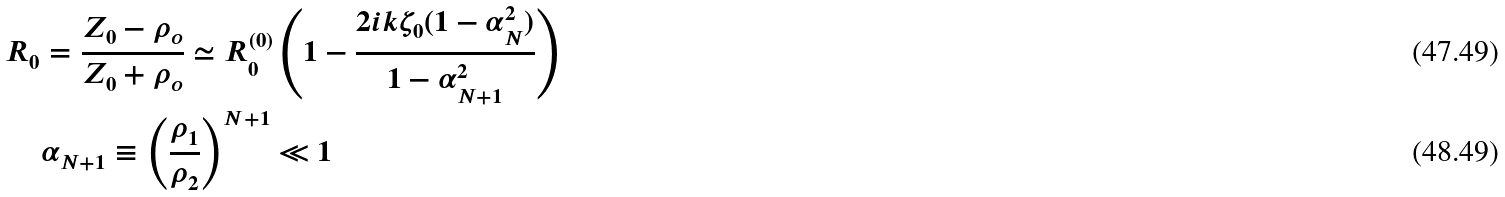Convert formula to latex. <formula><loc_0><loc_0><loc_500><loc_500>R _ { 0 } & = \frac { Z _ { 0 } - \rho _ { o } } { Z _ { 0 } + \rho _ { o } } \simeq R _ { 0 } ^ { ( 0 ) } \left ( 1 - \frac { 2 i k \zeta _ { 0 } ( 1 - \alpha _ { N } ^ { 2 } ) } { 1 - \alpha _ { N + 1 } ^ { 2 } } \right ) \\ & \alpha _ { N + 1 } \equiv \left ( \frac { \rho _ { 1 } } { \rho _ { 2 } } \right ) ^ { N + 1 } \ll 1</formula> 